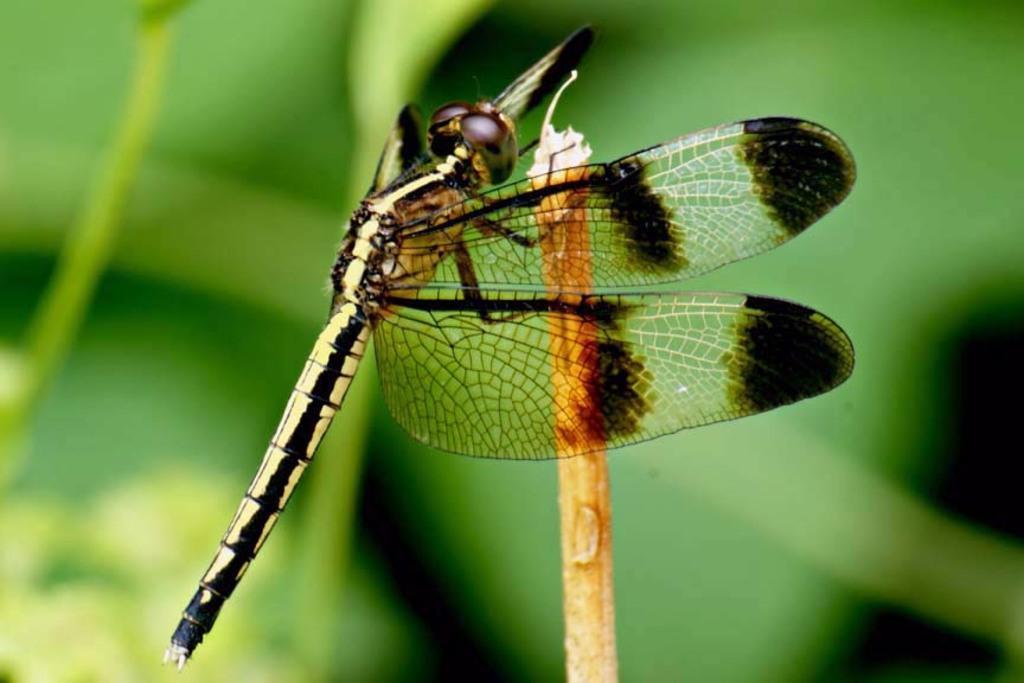Please provide a concise description of this image. In this image, in the middle, we can see a butterfly which is on the stem. In the background, we can see green color. 